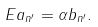Convert formula to latex. <formula><loc_0><loc_0><loc_500><loc_500>E a _ { n ^ { \prime } } = \alpha b _ { n ^ { \prime } } .</formula> 